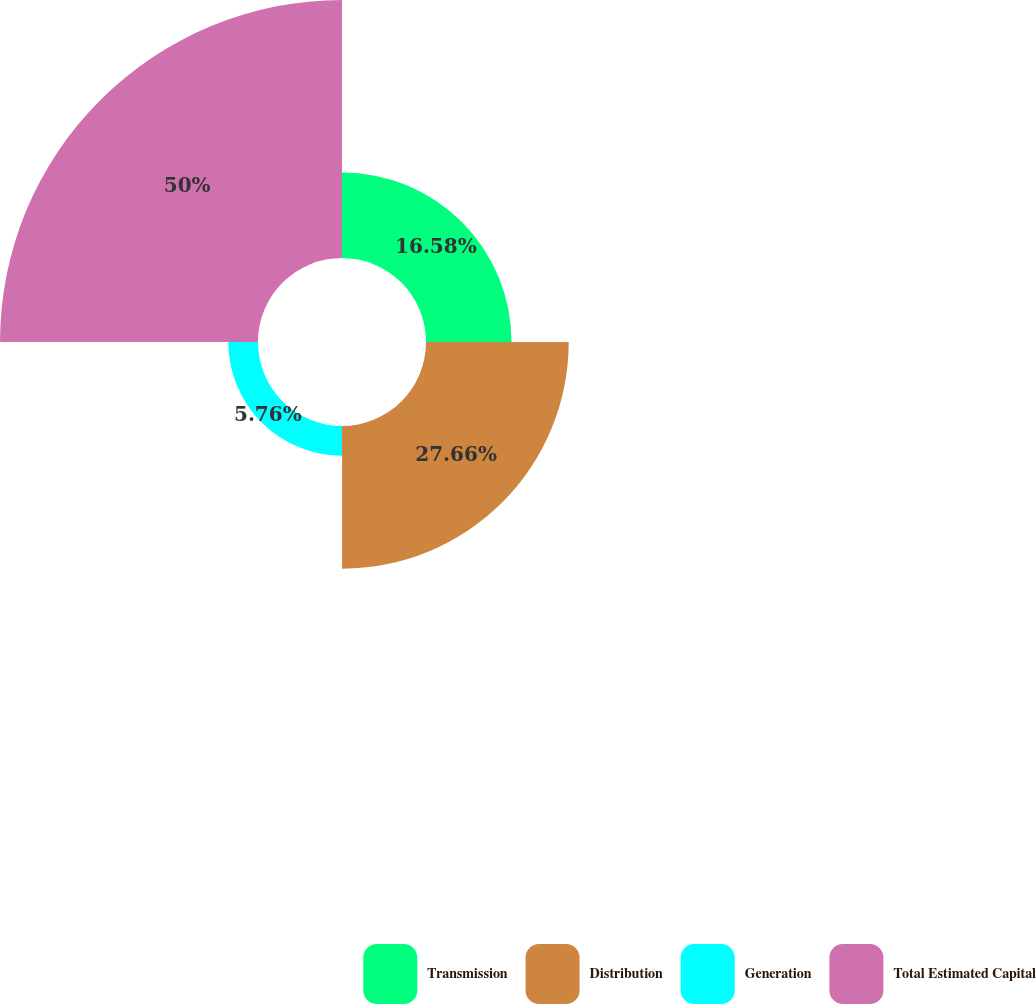Convert chart. <chart><loc_0><loc_0><loc_500><loc_500><pie_chart><fcel>Transmission<fcel>Distribution<fcel>Generation<fcel>Total Estimated Capital<nl><fcel>16.58%<fcel>27.66%<fcel>5.76%<fcel>50.0%<nl></chart> 